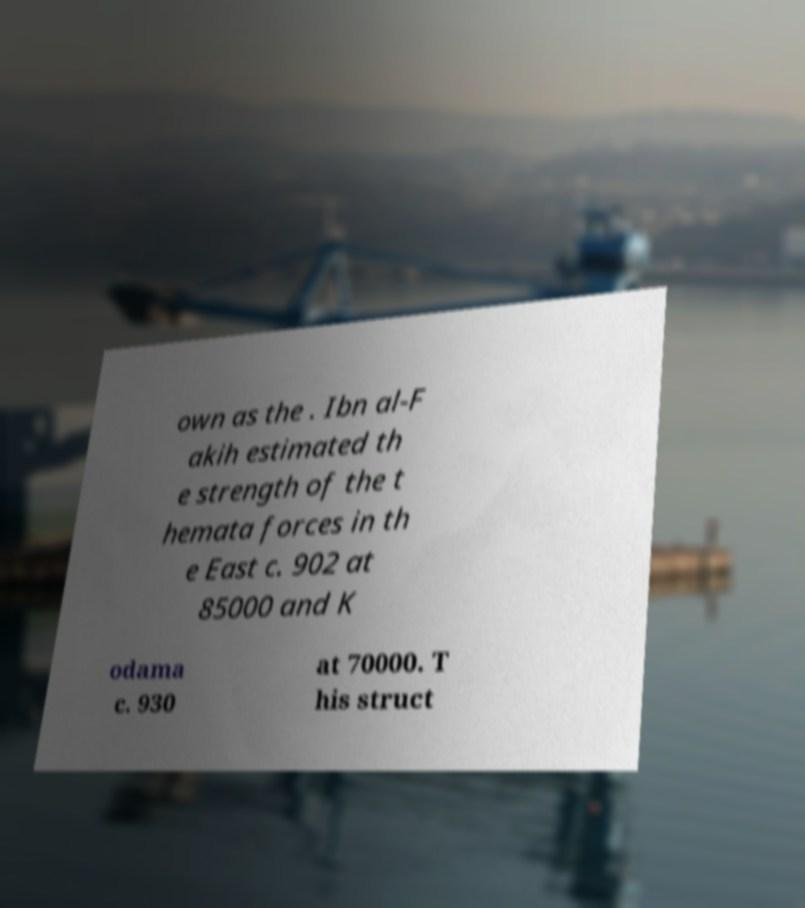I need the written content from this picture converted into text. Can you do that? own as the . Ibn al-F akih estimated th e strength of the t hemata forces in th e East c. 902 at 85000 and K odama c. 930 at 70000. T his struct 